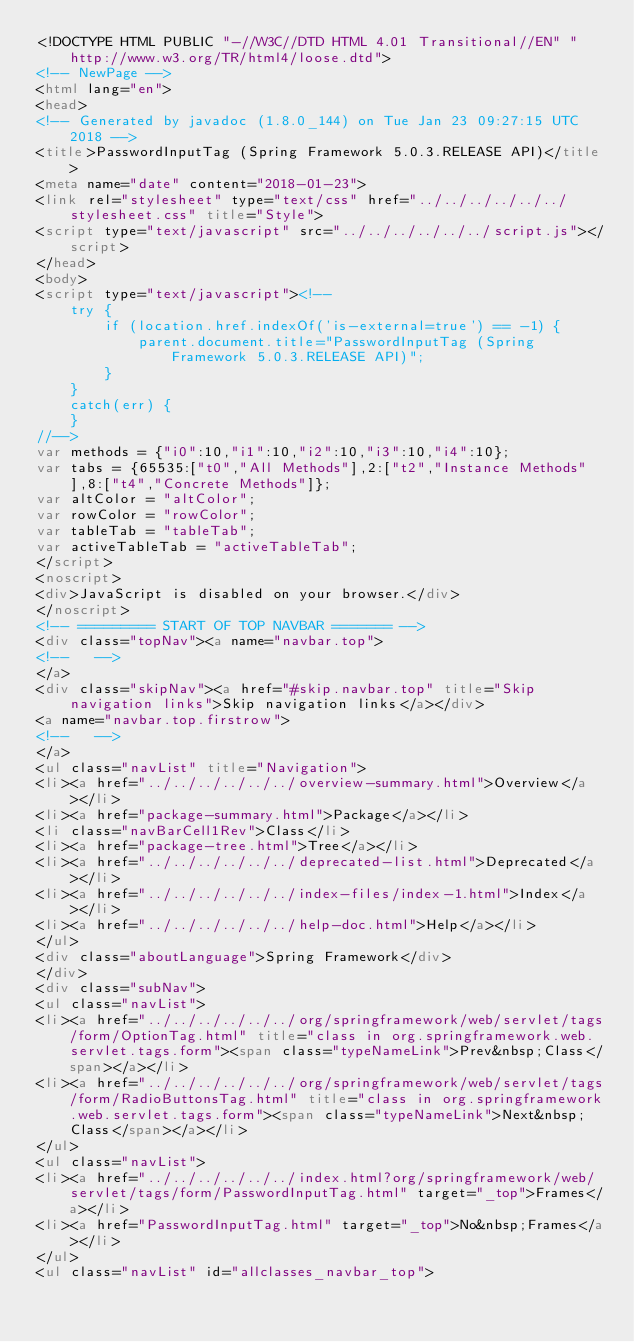Convert code to text. <code><loc_0><loc_0><loc_500><loc_500><_HTML_><!DOCTYPE HTML PUBLIC "-//W3C//DTD HTML 4.01 Transitional//EN" "http://www.w3.org/TR/html4/loose.dtd">
<!-- NewPage -->
<html lang="en">
<head>
<!-- Generated by javadoc (1.8.0_144) on Tue Jan 23 09:27:15 UTC 2018 -->
<title>PasswordInputTag (Spring Framework 5.0.3.RELEASE API)</title>
<meta name="date" content="2018-01-23">
<link rel="stylesheet" type="text/css" href="../../../../../../stylesheet.css" title="Style">
<script type="text/javascript" src="../../../../../../script.js"></script>
</head>
<body>
<script type="text/javascript"><!--
    try {
        if (location.href.indexOf('is-external=true') == -1) {
            parent.document.title="PasswordInputTag (Spring Framework 5.0.3.RELEASE API)";
        }
    }
    catch(err) {
    }
//-->
var methods = {"i0":10,"i1":10,"i2":10,"i3":10,"i4":10};
var tabs = {65535:["t0","All Methods"],2:["t2","Instance Methods"],8:["t4","Concrete Methods"]};
var altColor = "altColor";
var rowColor = "rowColor";
var tableTab = "tableTab";
var activeTableTab = "activeTableTab";
</script>
<noscript>
<div>JavaScript is disabled on your browser.</div>
</noscript>
<!-- ========= START OF TOP NAVBAR ======= -->
<div class="topNav"><a name="navbar.top">
<!--   -->
</a>
<div class="skipNav"><a href="#skip.navbar.top" title="Skip navigation links">Skip navigation links</a></div>
<a name="navbar.top.firstrow">
<!--   -->
</a>
<ul class="navList" title="Navigation">
<li><a href="../../../../../../overview-summary.html">Overview</a></li>
<li><a href="package-summary.html">Package</a></li>
<li class="navBarCell1Rev">Class</li>
<li><a href="package-tree.html">Tree</a></li>
<li><a href="../../../../../../deprecated-list.html">Deprecated</a></li>
<li><a href="../../../../../../index-files/index-1.html">Index</a></li>
<li><a href="../../../../../../help-doc.html">Help</a></li>
</ul>
<div class="aboutLanguage">Spring Framework</div>
</div>
<div class="subNav">
<ul class="navList">
<li><a href="../../../../../../org/springframework/web/servlet/tags/form/OptionTag.html" title="class in org.springframework.web.servlet.tags.form"><span class="typeNameLink">Prev&nbsp;Class</span></a></li>
<li><a href="../../../../../../org/springframework/web/servlet/tags/form/RadioButtonsTag.html" title="class in org.springframework.web.servlet.tags.form"><span class="typeNameLink">Next&nbsp;Class</span></a></li>
</ul>
<ul class="navList">
<li><a href="../../../../../../index.html?org/springframework/web/servlet/tags/form/PasswordInputTag.html" target="_top">Frames</a></li>
<li><a href="PasswordInputTag.html" target="_top">No&nbsp;Frames</a></li>
</ul>
<ul class="navList" id="allclasses_navbar_top"></code> 